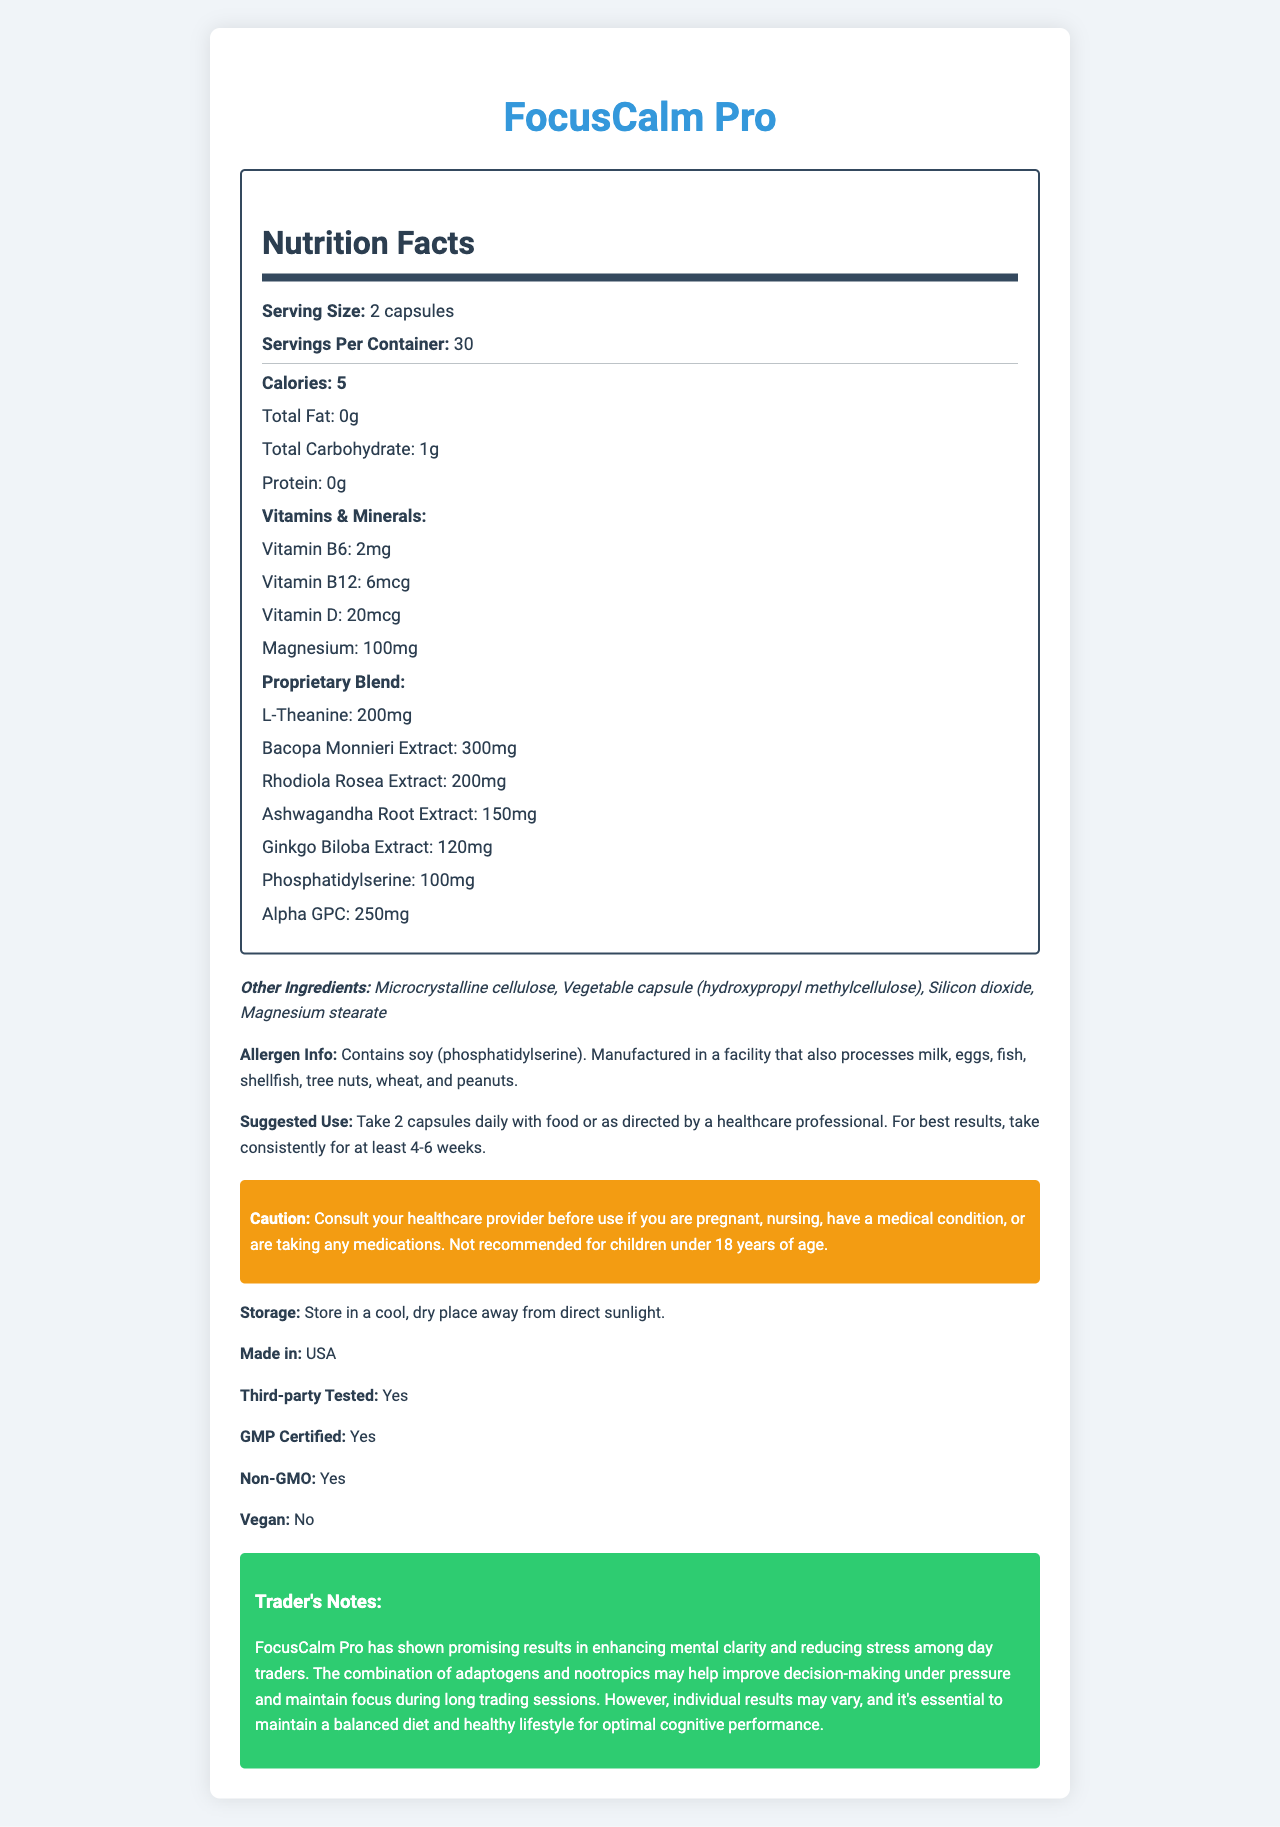what is the serving size? The document states that the serving size for FocusCalm Pro is 2 capsules.
Answer: 2 capsules how many servings are there per container? According to the document, there are 30 servings per container.
Answer: 30 what is the calorie count per serving? The document lists the calorie count per serving as 5.
Answer: 5 calories how much magnesium is in each serving? The document indicates that each serving contains 100mg of magnesium.
Answer: 100mg what are the proprietary blend ingredients? The proprietary blend ingredients are listed under the "Proprietary Blend" section in the document.
Answer: L-Theanine, Bacopa Monnieri Extract, Rhodiola Rosea Extract, Ashwagandha Root Extract, Ginkgo Biloba Extract, Phosphatidylserine, Alpha GPC what is the suggested use for this supplement? The document specifies that the suggested use is to take 2 capsules daily with food or as directed by a healthcare professional, and for best results, to take the supplement consistently for at least 4-6 weeks.
Answer: Take 2 capsules daily with food or as directed by a healthcare professional. For best results, take consistently for at least 4-6 weeks. which ingredient might cause an allergic reaction for someone with a soy allergy? A. Microcrystalline cellulose B. Phosphatidylserine C. Magnesium stearate The allergen information in the document indicates that phosphatidylserine contains soy.
Answer: B what is the source of the other ingredients? A. Vegetables B. Animals C. Synthetic D. Multiple sources The document lists "Vegetable capsule (hydroxypropyl methylcellulose)" among the other ingredients, indicating a vegetable source.
Answer: A is this supplement third-party tested? The document states that FocusCalm Pro is third-party tested.
Answer: Yes is FocusCalm Pro a vegan product? The document indicates that FocusCalm Pro is not vegan.
Answer: No what are the benefits mentioned in the trader notes? The trader notes in the document provide these benefits of FocusCalm Pro.
Answer: Enhancing mental clarity and reducing stress among day traders, improving decision-making under pressure, and maintaining focus during long trading sessions. who should consult a healthcare provider before using this supplement? The document's caution section advises individuals in these categories to consult a healthcare provider before use.
Answer: Anyone who is pregnant, nursing, has a medical condition, or is taking any medications. summarize the main idea of this document. The document outlines key details about FocusCalm Pro, a supplement designed to enhance mental focus and reduce stress, including its nutritional content, proprietary blend, usage instructions, and safety precautions.
Answer: The document provides detailed information about the FocusCalm Pro vitamin supplement, including its nutritional facts, ingredients, suggested use, allergen information, and benefits for mental focus and stress reduction. which production standards are followed for this product? The document states that FocusCalm Pro is GMP certified and made in the USA.
Answer: GMP certified and made in the USA. what is the exact amount of Vitamin D per serving? The document lists the amount of Vitamin D per serving as 20mcg.
Answer: 20mcg how long does one container last, based on the suggested use? The container has 30 servings, and the suggested use is 2 capsules daily, making it last 30 days.
Answer: 30 days what are the benefits of Bacopa Monnieri Extract according to the document? The document lists Bacopa Monnieri Extract as an ingredient but does not specify its benefits.
Answer: Not enough information which ingredients are not part of the proprietary blend? These ingredients are included in the "Other Ingredients" section and are not part of the proprietary blend.
Answer: Microcrystalline cellulose, Vegetable capsule (hydroxypropyl methylcellulose), Silicon dioxide, Magnesium stearate 